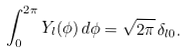Convert formula to latex. <formula><loc_0><loc_0><loc_500><loc_500>\int _ { 0 } ^ { 2 \pi } Y _ { l } ( \phi ) \, d \phi = \sqrt { 2 \pi } \, \delta _ { l 0 } .</formula> 